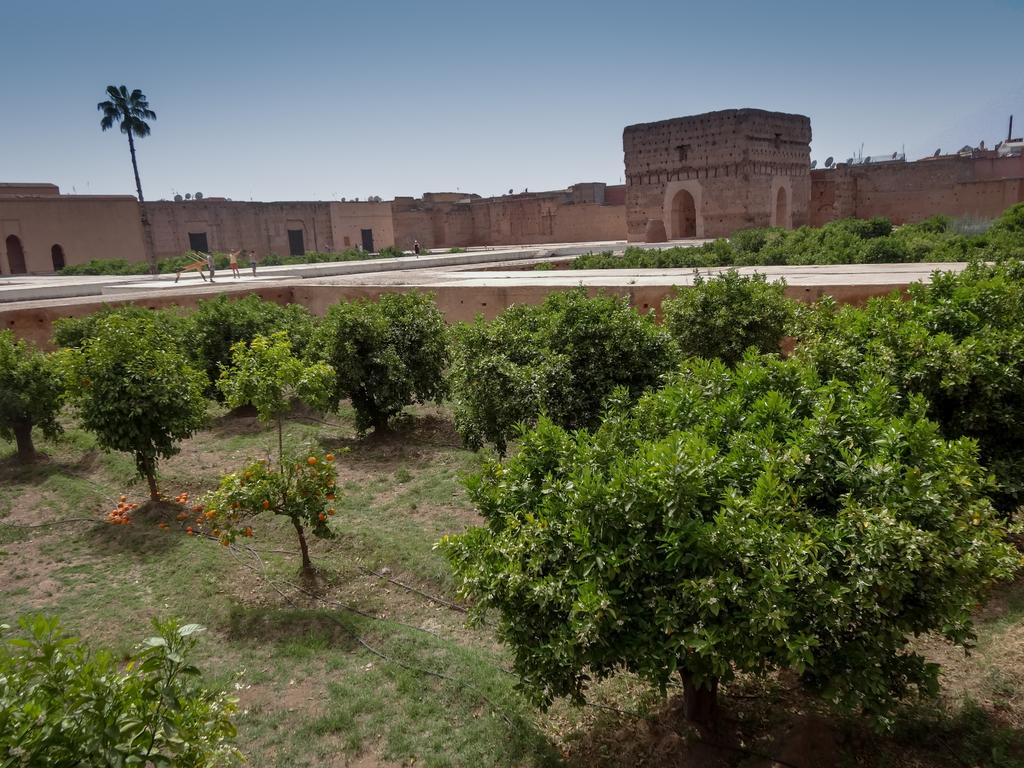What type of natural elements can be seen in the image? There are trees in the image. What man-made feature is present in the image? There is a path in the image. What can be seen in the distance in the image? There are buildings in the background of the image. What is visible in the sky in the image? The sky is visible in the background of the image. Can you see the tail of the jellyfish in the image? There is no jellyfish, let alone a tail, present in the image. 